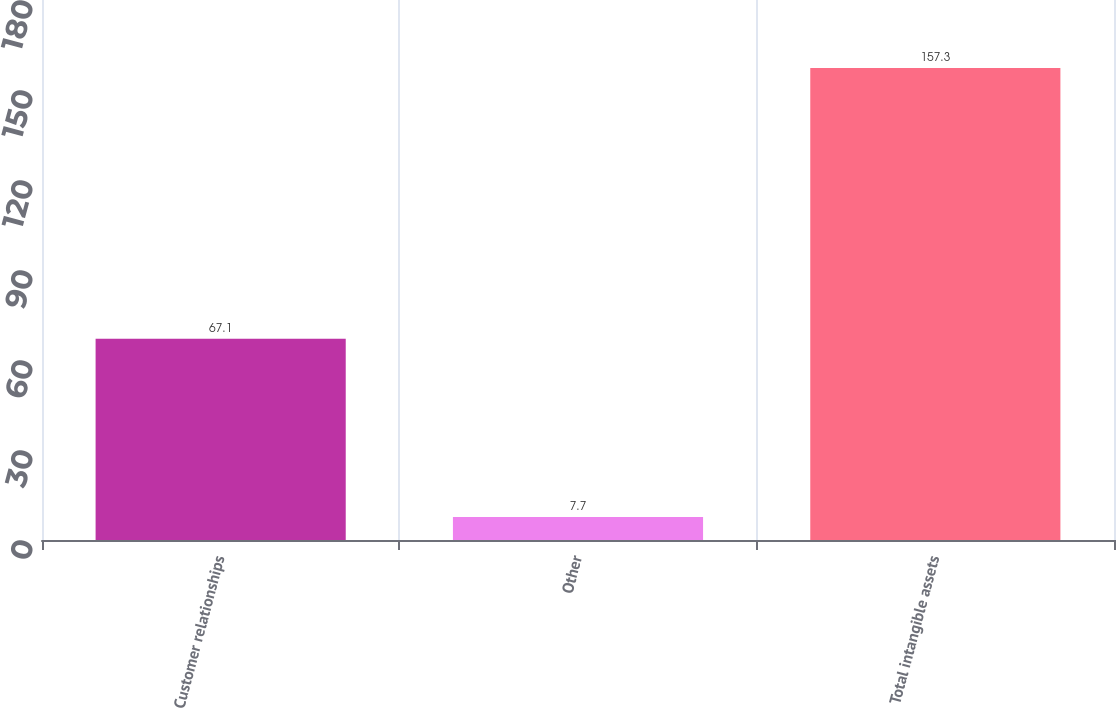Convert chart. <chart><loc_0><loc_0><loc_500><loc_500><bar_chart><fcel>Customer relationships<fcel>Other<fcel>Total intangible assets<nl><fcel>67.1<fcel>7.7<fcel>157.3<nl></chart> 